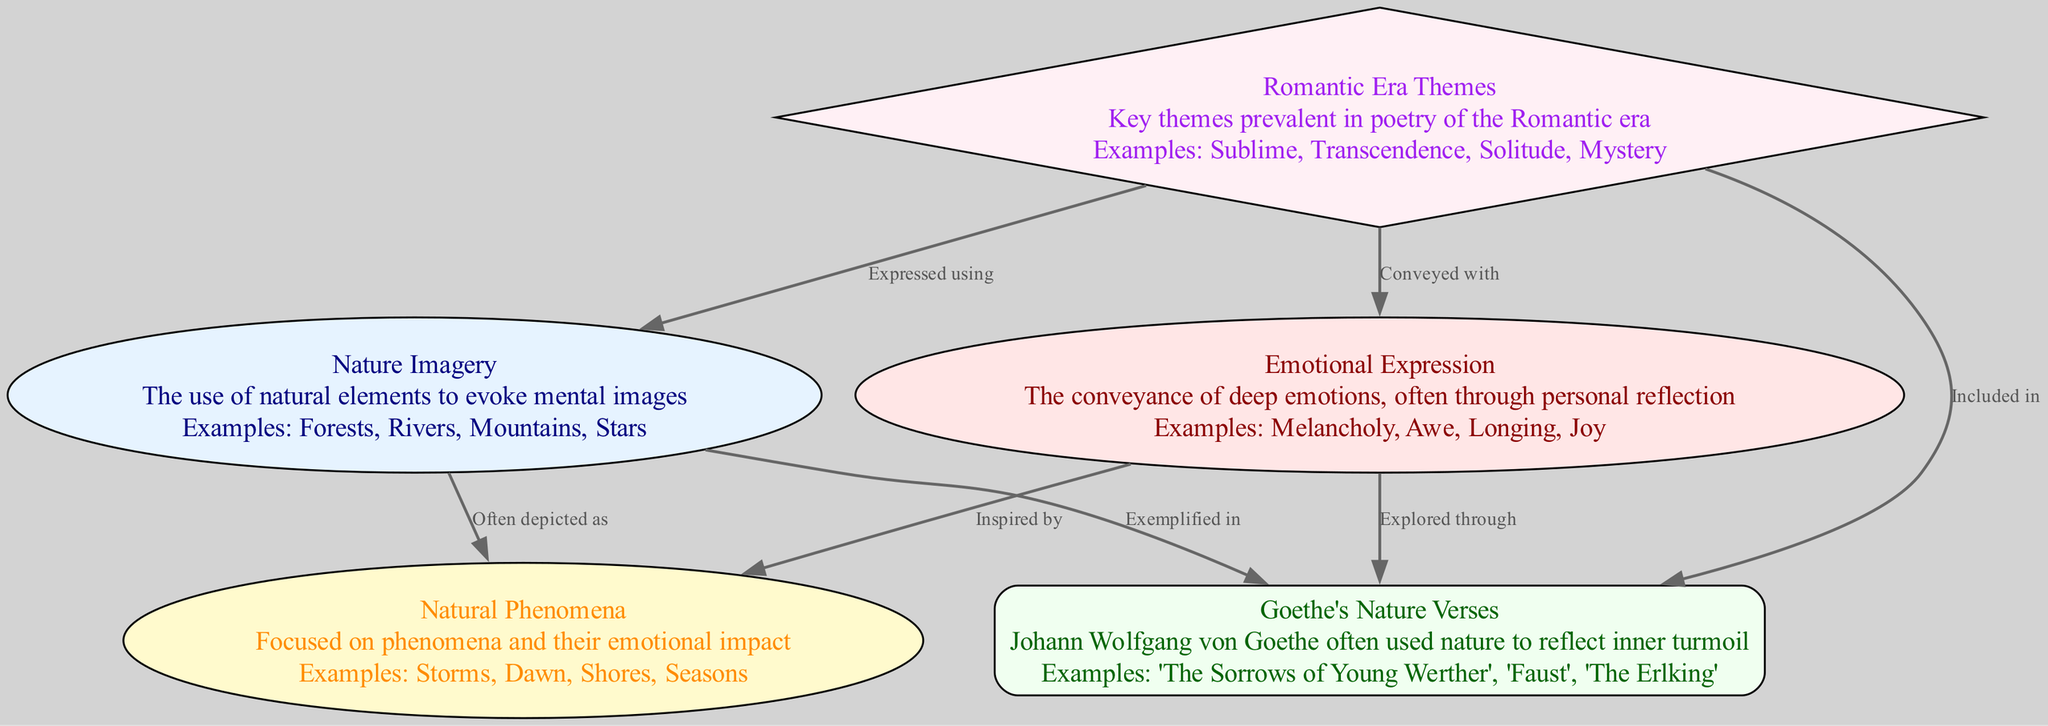What node exemplifies the relation "Exemplified in" with Goethe's Nature Verses? The edge labeled "Exemplified in" connects Nature Imagery (node 1) to Goethe's Nature Verses (node 3). This indicates that Nature Imagery is explicitly seen in Goethe's works.
Answer: Nature Imagery What is the emotional expression conveyed with the relationship to Romantic Era Themes? The edge labeled "Conveyed with" connects Emotional Expression (node 2) to Romantic Era Themes (node 4). This highlights that Emotional Expression is articulated through the themes found in Romantic Era poetry.
Answer: Romantic Era Themes How many nodes are present in the diagram? The diagram lists five distinct elements related to the theme being studied. Each element is represented as a node, and counting them provides the total number.
Answer: Five Which node is focused on phenomena and their emotional impact? The description for Natural Phenomena (node 5) indicates that this node centers around various natural events and their associated emotional effects.
Answer: Natural Phenomena What is the relationship between Nature Imagery and Natural Phenomena? The relationship labeled "Often depicted as" connects Nature Imagery (node 1) to Natural Phenomena (node 5), suggesting that Nature Imagery frequently illustrates Natural Phenomena in poems.
Answer: Often depicted as What does Romantic Era Themes express using Nature Imagery? The relationship labeled "Expressed using" indicates that Romantic Era Themes (node 4) utilizes Nature Imagery (node 1) to convey deeper concepts and feelings, emphasizing the connection between nature and the themes of the era.
Answer: Nature Imagery Which poetic work of Goethe deals with emotional expression through nature? Under the node Goethe's Nature Verses (node 3), several works are listed, one of which is "The Sorrows of Young Werther." This title exemplifies how Goethe combines nature with emotional reflection.
Answer: The Sorrows of Young Werther 